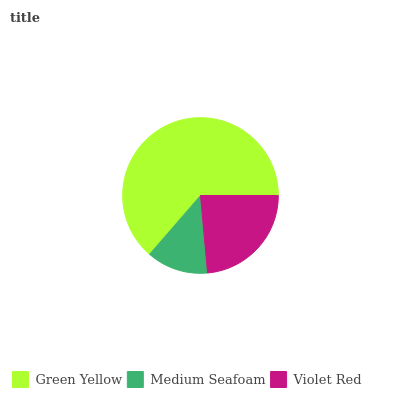Is Medium Seafoam the minimum?
Answer yes or no. Yes. Is Green Yellow the maximum?
Answer yes or no. Yes. Is Violet Red the minimum?
Answer yes or no. No. Is Violet Red the maximum?
Answer yes or no. No. Is Violet Red greater than Medium Seafoam?
Answer yes or no. Yes. Is Medium Seafoam less than Violet Red?
Answer yes or no. Yes. Is Medium Seafoam greater than Violet Red?
Answer yes or no. No. Is Violet Red less than Medium Seafoam?
Answer yes or no. No. Is Violet Red the high median?
Answer yes or no. Yes. Is Violet Red the low median?
Answer yes or no. Yes. Is Medium Seafoam the high median?
Answer yes or no. No. Is Green Yellow the low median?
Answer yes or no. No. 